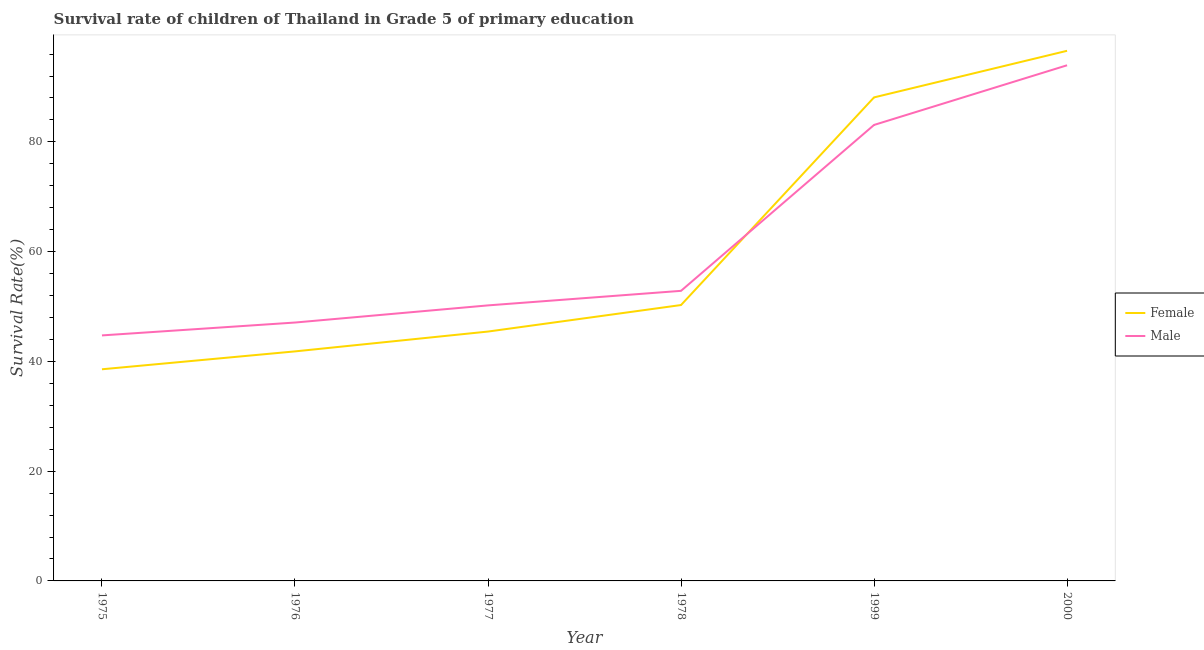How many different coloured lines are there?
Keep it short and to the point. 2. Is the number of lines equal to the number of legend labels?
Your response must be concise. Yes. What is the survival rate of female students in primary education in 1976?
Provide a short and direct response. 41.82. Across all years, what is the maximum survival rate of male students in primary education?
Provide a short and direct response. 93.96. Across all years, what is the minimum survival rate of female students in primary education?
Provide a short and direct response. 38.56. In which year was the survival rate of female students in primary education minimum?
Your answer should be compact. 1975. What is the total survival rate of male students in primary education in the graph?
Offer a terse response. 371.91. What is the difference between the survival rate of male students in primary education in 1977 and that in 2000?
Your answer should be compact. -43.75. What is the difference between the survival rate of male students in primary education in 1977 and the survival rate of female students in primary education in 2000?
Your response must be concise. -46.39. What is the average survival rate of female students in primary education per year?
Give a very brief answer. 60.13. In the year 1976, what is the difference between the survival rate of male students in primary education and survival rate of female students in primary education?
Your answer should be very brief. 5.26. What is the ratio of the survival rate of male students in primary education in 1976 to that in 1978?
Give a very brief answer. 0.89. Is the survival rate of female students in primary education in 1976 less than that in 1977?
Your answer should be very brief. Yes. What is the difference between the highest and the second highest survival rate of female students in primary education?
Your answer should be very brief. 8.49. What is the difference between the highest and the lowest survival rate of male students in primary education?
Your response must be concise. 49.22. Is the survival rate of male students in primary education strictly greater than the survival rate of female students in primary education over the years?
Provide a short and direct response. No. How many lines are there?
Your answer should be compact. 2. Does the graph contain any zero values?
Ensure brevity in your answer.  No. Does the graph contain grids?
Your response must be concise. No. What is the title of the graph?
Your response must be concise. Survival rate of children of Thailand in Grade 5 of primary education. What is the label or title of the X-axis?
Your answer should be very brief. Year. What is the label or title of the Y-axis?
Your response must be concise. Survival Rate(%). What is the Survival Rate(%) of Female in 1975?
Your answer should be very brief. 38.56. What is the Survival Rate(%) of Male in 1975?
Offer a very short reply. 44.73. What is the Survival Rate(%) in Female in 1976?
Provide a succinct answer. 41.82. What is the Survival Rate(%) in Male in 1976?
Your response must be concise. 47.08. What is the Survival Rate(%) of Female in 1977?
Offer a terse response. 45.44. What is the Survival Rate(%) of Male in 1977?
Give a very brief answer. 50.2. What is the Survival Rate(%) of Female in 1978?
Keep it short and to the point. 50.27. What is the Survival Rate(%) of Male in 1978?
Your answer should be compact. 52.86. What is the Survival Rate(%) of Female in 1999?
Provide a short and direct response. 88.1. What is the Survival Rate(%) of Male in 1999?
Provide a succinct answer. 83.08. What is the Survival Rate(%) of Female in 2000?
Your answer should be very brief. 96.59. What is the Survival Rate(%) of Male in 2000?
Keep it short and to the point. 93.96. Across all years, what is the maximum Survival Rate(%) of Female?
Give a very brief answer. 96.59. Across all years, what is the maximum Survival Rate(%) in Male?
Give a very brief answer. 93.96. Across all years, what is the minimum Survival Rate(%) of Female?
Provide a succinct answer. 38.56. Across all years, what is the minimum Survival Rate(%) of Male?
Offer a terse response. 44.73. What is the total Survival Rate(%) of Female in the graph?
Keep it short and to the point. 360.79. What is the total Survival Rate(%) of Male in the graph?
Offer a very short reply. 371.91. What is the difference between the Survival Rate(%) of Female in 1975 and that in 1976?
Give a very brief answer. -3.26. What is the difference between the Survival Rate(%) of Male in 1975 and that in 1976?
Offer a very short reply. -2.35. What is the difference between the Survival Rate(%) in Female in 1975 and that in 1977?
Your answer should be very brief. -6.87. What is the difference between the Survival Rate(%) in Male in 1975 and that in 1977?
Your answer should be compact. -5.47. What is the difference between the Survival Rate(%) of Female in 1975 and that in 1978?
Keep it short and to the point. -11.71. What is the difference between the Survival Rate(%) in Male in 1975 and that in 1978?
Your answer should be very brief. -8.12. What is the difference between the Survival Rate(%) of Female in 1975 and that in 1999?
Ensure brevity in your answer.  -49.54. What is the difference between the Survival Rate(%) of Male in 1975 and that in 1999?
Offer a terse response. -38.35. What is the difference between the Survival Rate(%) in Female in 1975 and that in 2000?
Give a very brief answer. -58.03. What is the difference between the Survival Rate(%) of Male in 1975 and that in 2000?
Provide a short and direct response. -49.22. What is the difference between the Survival Rate(%) in Female in 1976 and that in 1977?
Your answer should be compact. -3.61. What is the difference between the Survival Rate(%) of Male in 1976 and that in 1977?
Your response must be concise. -3.12. What is the difference between the Survival Rate(%) of Female in 1976 and that in 1978?
Give a very brief answer. -8.45. What is the difference between the Survival Rate(%) in Male in 1976 and that in 1978?
Your answer should be very brief. -5.78. What is the difference between the Survival Rate(%) of Female in 1976 and that in 1999?
Keep it short and to the point. -46.28. What is the difference between the Survival Rate(%) in Male in 1976 and that in 1999?
Your answer should be very brief. -36. What is the difference between the Survival Rate(%) in Female in 1976 and that in 2000?
Your answer should be very brief. -54.77. What is the difference between the Survival Rate(%) in Male in 1976 and that in 2000?
Provide a short and direct response. -46.88. What is the difference between the Survival Rate(%) in Female in 1977 and that in 1978?
Your answer should be very brief. -4.83. What is the difference between the Survival Rate(%) of Male in 1977 and that in 1978?
Your answer should be compact. -2.65. What is the difference between the Survival Rate(%) in Female in 1977 and that in 1999?
Offer a terse response. -42.67. What is the difference between the Survival Rate(%) of Male in 1977 and that in 1999?
Provide a short and direct response. -32.88. What is the difference between the Survival Rate(%) of Female in 1977 and that in 2000?
Offer a very short reply. -51.16. What is the difference between the Survival Rate(%) in Male in 1977 and that in 2000?
Offer a terse response. -43.75. What is the difference between the Survival Rate(%) of Female in 1978 and that in 1999?
Provide a short and direct response. -37.83. What is the difference between the Survival Rate(%) in Male in 1978 and that in 1999?
Provide a short and direct response. -30.23. What is the difference between the Survival Rate(%) in Female in 1978 and that in 2000?
Keep it short and to the point. -46.32. What is the difference between the Survival Rate(%) of Male in 1978 and that in 2000?
Ensure brevity in your answer.  -41.1. What is the difference between the Survival Rate(%) of Female in 1999 and that in 2000?
Offer a terse response. -8.49. What is the difference between the Survival Rate(%) of Male in 1999 and that in 2000?
Your answer should be compact. -10.87. What is the difference between the Survival Rate(%) of Female in 1975 and the Survival Rate(%) of Male in 1976?
Make the answer very short. -8.52. What is the difference between the Survival Rate(%) in Female in 1975 and the Survival Rate(%) in Male in 1977?
Offer a very short reply. -11.64. What is the difference between the Survival Rate(%) of Female in 1975 and the Survival Rate(%) of Male in 1978?
Offer a very short reply. -14.29. What is the difference between the Survival Rate(%) in Female in 1975 and the Survival Rate(%) in Male in 1999?
Offer a very short reply. -44.52. What is the difference between the Survival Rate(%) of Female in 1975 and the Survival Rate(%) of Male in 2000?
Offer a very short reply. -55.39. What is the difference between the Survival Rate(%) in Female in 1976 and the Survival Rate(%) in Male in 1977?
Your response must be concise. -8.38. What is the difference between the Survival Rate(%) of Female in 1976 and the Survival Rate(%) of Male in 1978?
Offer a terse response. -11.03. What is the difference between the Survival Rate(%) of Female in 1976 and the Survival Rate(%) of Male in 1999?
Make the answer very short. -41.26. What is the difference between the Survival Rate(%) in Female in 1976 and the Survival Rate(%) in Male in 2000?
Give a very brief answer. -52.13. What is the difference between the Survival Rate(%) in Female in 1977 and the Survival Rate(%) in Male in 1978?
Your answer should be very brief. -7.42. What is the difference between the Survival Rate(%) in Female in 1977 and the Survival Rate(%) in Male in 1999?
Ensure brevity in your answer.  -37.65. What is the difference between the Survival Rate(%) in Female in 1977 and the Survival Rate(%) in Male in 2000?
Your response must be concise. -48.52. What is the difference between the Survival Rate(%) of Female in 1978 and the Survival Rate(%) of Male in 1999?
Provide a succinct answer. -32.81. What is the difference between the Survival Rate(%) in Female in 1978 and the Survival Rate(%) in Male in 2000?
Give a very brief answer. -43.69. What is the difference between the Survival Rate(%) in Female in 1999 and the Survival Rate(%) in Male in 2000?
Give a very brief answer. -5.85. What is the average Survival Rate(%) of Female per year?
Offer a very short reply. 60.13. What is the average Survival Rate(%) in Male per year?
Provide a succinct answer. 61.99. In the year 1975, what is the difference between the Survival Rate(%) of Female and Survival Rate(%) of Male?
Provide a short and direct response. -6.17. In the year 1976, what is the difference between the Survival Rate(%) in Female and Survival Rate(%) in Male?
Offer a terse response. -5.26. In the year 1977, what is the difference between the Survival Rate(%) in Female and Survival Rate(%) in Male?
Your answer should be compact. -4.77. In the year 1978, what is the difference between the Survival Rate(%) in Female and Survival Rate(%) in Male?
Give a very brief answer. -2.59. In the year 1999, what is the difference between the Survival Rate(%) of Female and Survival Rate(%) of Male?
Keep it short and to the point. 5.02. In the year 2000, what is the difference between the Survival Rate(%) in Female and Survival Rate(%) in Male?
Offer a very short reply. 2.64. What is the ratio of the Survival Rate(%) in Female in 1975 to that in 1976?
Make the answer very short. 0.92. What is the ratio of the Survival Rate(%) in Male in 1975 to that in 1976?
Give a very brief answer. 0.95. What is the ratio of the Survival Rate(%) of Female in 1975 to that in 1977?
Your response must be concise. 0.85. What is the ratio of the Survival Rate(%) in Male in 1975 to that in 1977?
Keep it short and to the point. 0.89. What is the ratio of the Survival Rate(%) of Female in 1975 to that in 1978?
Your answer should be very brief. 0.77. What is the ratio of the Survival Rate(%) of Male in 1975 to that in 1978?
Offer a very short reply. 0.85. What is the ratio of the Survival Rate(%) in Female in 1975 to that in 1999?
Your answer should be compact. 0.44. What is the ratio of the Survival Rate(%) of Male in 1975 to that in 1999?
Your response must be concise. 0.54. What is the ratio of the Survival Rate(%) of Female in 1975 to that in 2000?
Make the answer very short. 0.4. What is the ratio of the Survival Rate(%) of Male in 1975 to that in 2000?
Your response must be concise. 0.48. What is the ratio of the Survival Rate(%) of Female in 1976 to that in 1977?
Give a very brief answer. 0.92. What is the ratio of the Survival Rate(%) of Male in 1976 to that in 1977?
Your response must be concise. 0.94. What is the ratio of the Survival Rate(%) in Female in 1976 to that in 1978?
Your answer should be compact. 0.83. What is the ratio of the Survival Rate(%) in Male in 1976 to that in 1978?
Make the answer very short. 0.89. What is the ratio of the Survival Rate(%) of Female in 1976 to that in 1999?
Offer a very short reply. 0.47. What is the ratio of the Survival Rate(%) of Male in 1976 to that in 1999?
Keep it short and to the point. 0.57. What is the ratio of the Survival Rate(%) in Female in 1976 to that in 2000?
Give a very brief answer. 0.43. What is the ratio of the Survival Rate(%) in Male in 1976 to that in 2000?
Offer a very short reply. 0.5. What is the ratio of the Survival Rate(%) in Female in 1977 to that in 1978?
Give a very brief answer. 0.9. What is the ratio of the Survival Rate(%) in Male in 1977 to that in 1978?
Provide a succinct answer. 0.95. What is the ratio of the Survival Rate(%) in Female in 1977 to that in 1999?
Give a very brief answer. 0.52. What is the ratio of the Survival Rate(%) of Male in 1977 to that in 1999?
Offer a terse response. 0.6. What is the ratio of the Survival Rate(%) of Female in 1977 to that in 2000?
Provide a succinct answer. 0.47. What is the ratio of the Survival Rate(%) of Male in 1977 to that in 2000?
Your answer should be very brief. 0.53. What is the ratio of the Survival Rate(%) of Female in 1978 to that in 1999?
Provide a succinct answer. 0.57. What is the ratio of the Survival Rate(%) of Male in 1978 to that in 1999?
Offer a terse response. 0.64. What is the ratio of the Survival Rate(%) of Female in 1978 to that in 2000?
Your response must be concise. 0.52. What is the ratio of the Survival Rate(%) in Male in 1978 to that in 2000?
Ensure brevity in your answer.  0.56. What is the ratio of the Survival Rate(%) of Female in 1999 to that in 2000?
Provide a succinct answer. 0.91. What is the ratio of the Survival Rate(%) in Male in 1999 to that in 2000?
Give a very brief answer. 0.88. What is the difference between the highest and the second highest Survival Rate(%) of Female?
Provide a succinct answer. 8.49. What is the difference between the highest and the second highest Survival Rate(%) of Male?
Your answer should be compact. 10.87. What is the difference between the highest and the lowest Survival Rate(%) in Female?
Ensure brevity in your answer.  58.03. What is the difference between the highest and the lowest Survival Rate(%) of Male?
Your response must be concise. 49.22. 